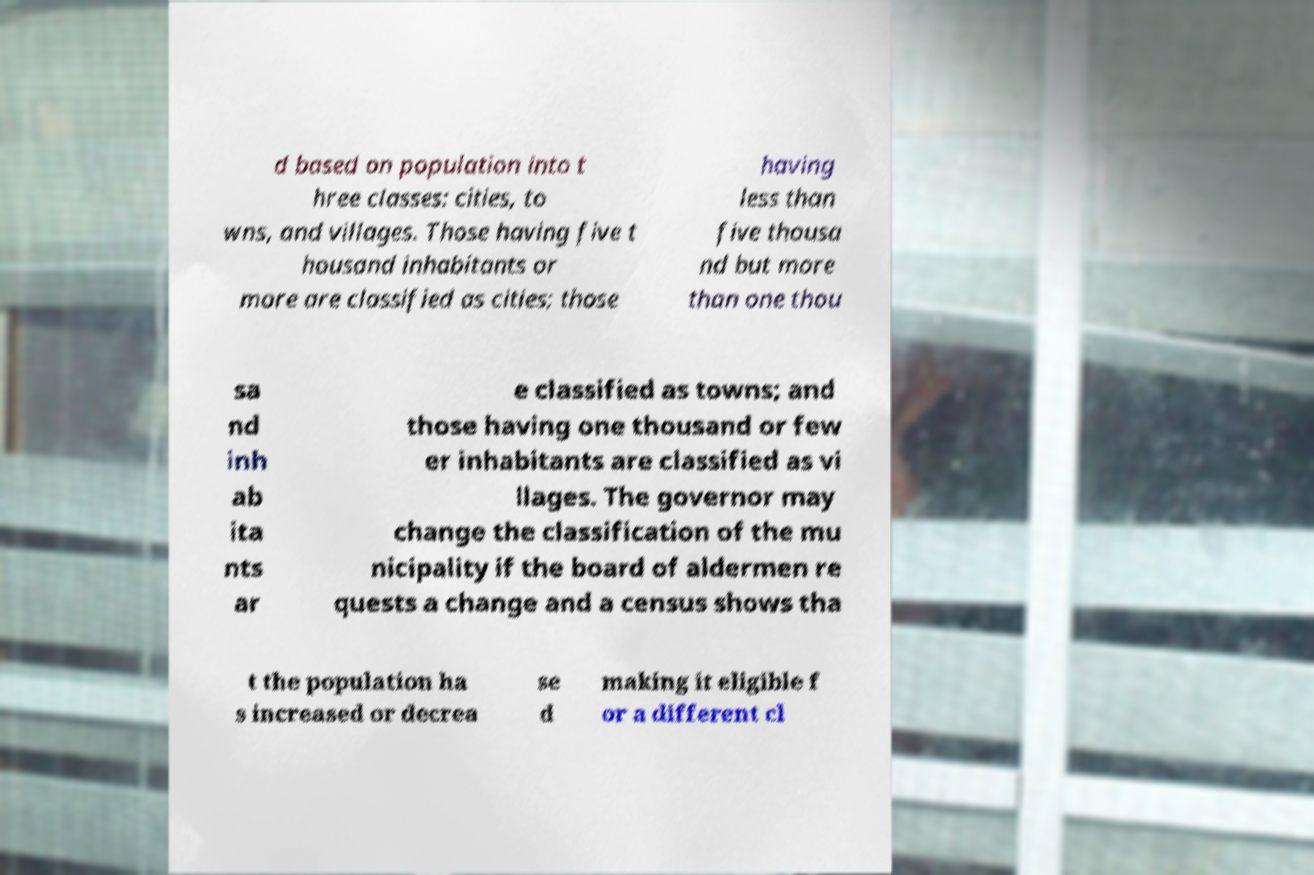For documentation purposes, I need the text within this image transcribed. Could you provide that? d based on population into t hree classes: cities, to wns, and villages. Those having five t housand inhabitants or more are classified as cities; those having less than five thousa nd but more than one thou sa nd inh ab ita nts ar e classified as towns; and those having one thousand or few er inhabitants are classified as vi llages. The governor may change the classification of the mu nicipality if the board of aldermen re quests a change and a census shows tha t the population ha s increased or decrea se d making it eligible f or a different cl 